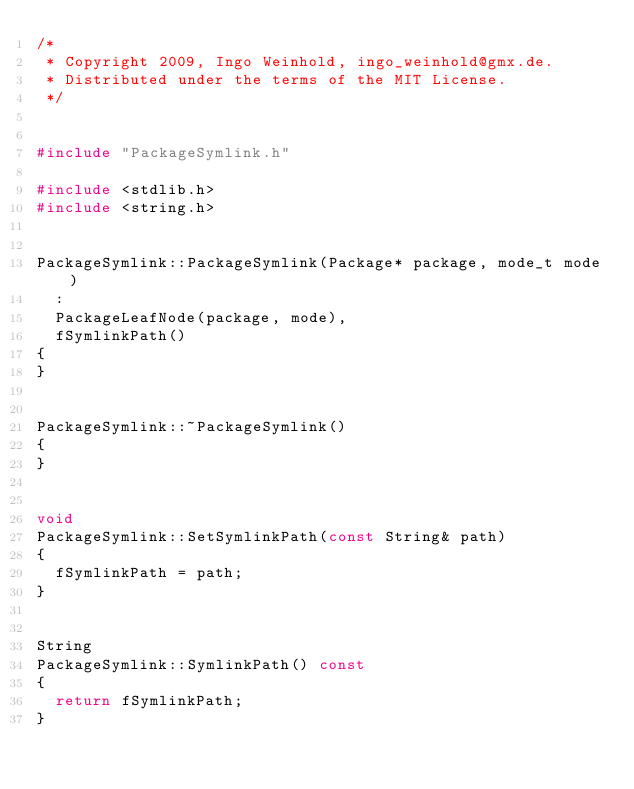<code> <loc_0><loc_0><loc_500><loc_500><_C++_>/*
 * Copyright 2009, Ingo Weinhold, ingo_weinhold@gmx.de.
 * Distributed under the terms of the MIT License.
 */


#include "PackageSymlink.h"

#include <stdlib.h>
#include <string.h>


PackageSymlink::PackageSymlink(Package* package, mode_t mode)
	:
	PackageLeafNode(package, mode),
	fSymlinkPath()
{
}


PackageSymlink::~PackageSymlink()
{
}


void
PackageSymlink::SetSymlinkPath(const String& path)
{
	fSymlinkPath = path;
}


String
PackageSymlink::SymlinkPath() const
{
	return fSymlinkPath;
}
</code> 